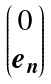Convert formula to latex. <formula><loc_0><loc_0><loc_500><loc_500>\begin{pmatrix} 0 \\ e _ { n } \end{pmatrix}</formula> 